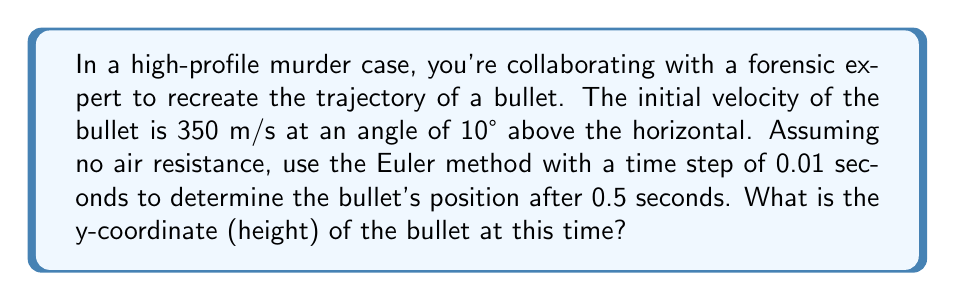Teach me how to tackle this problem. To solve this problem using the Euler method, we'll follow these steps:

1) First, let's define our variables:
   $v_0 = 350$ m/s (initial velocity)
   $\theta = 10°$ (angle above horizontal)
   $\Delta t = 0.01$ s (time step)
   $t_{final} = 0.5$ s (final time)
   $g = 9.8$ m/s² (acceleration due to gravity)

2) We need to break the initial velocity into x and y components:
   $v_{0x} = v_0 \cos(\theta) = 350 \cos(10°) = 344.71$ m/s
   $v_{0y} = v_0 \sin(\theta) = 350 \sin(10°) = 60.78$ m/s

3) The Euler method updates position and velocity at each time step:
   $x_{n+1} = x_n + v_x \Delta t$
   $y_{n+1} = y_n + v_y \Delta t$
   $v_{y,n+1} = v_{y,n} - g \Delta t$

4) We'll start at $t=0$ with:
   $x_0 = 0$, $y_0 = 0$, $v_{x,0} = 344.71$, $v_{y,0} = 60.78$

5) We need to iterate 50 times (0.5 s / 0.01 s = 50):

   For $n = 0$ to $49$:
   $x_{n+1} = x_n + 344.71 \times 0.01$
   $y_{n+1} = y_n + v_{y,n} \times 0.01$
   $v_{y,n+1} = v_{y,n} - 9.8 \times 0.01$

6) After 50 iterations:
   $x_{50} = 172.36$ m
   $y_{50} = 28.16$ m
   $v_{y,50} = 55.88$ m/s

Therefore, after 0.5 seconds, the bullet's y-coordinate (height) is 28.16 meters.
Answer: 28.16 m 